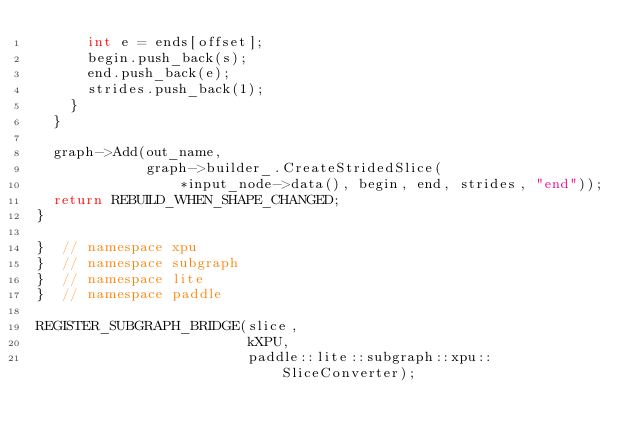Convert code to text. <code><loc_0><loc_0><loc_500><loc_500><_C++_>      int e = ends[offset];
      begin.push_back(s);
      end.push_back(e);
      strides.push_back(1);
    }
  }

  graph->Add(out_name,
             graph->builder_.CreateStridedSlice(
                 *input_node->data(), begin, end, strides, "end"));
  return REBUILD_WHEN_SHAPE_CHANGED;
}

}  // namespace xpu
}  // namespace subgraph
}  // namespace lite
}  // namespace paddle

REGISTER_SUBGRAPH_BRIDGE(slice,
                         kXPU,
                         paddle::lite::subgraph::xpu::SliceConverter);
</code> 